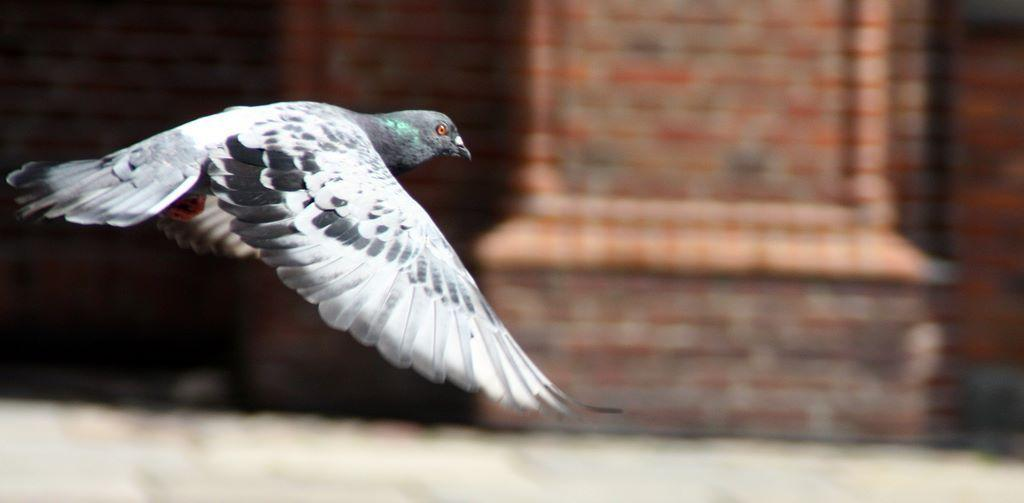What is the main subject of the image? There is a bird in the image. What is the bird doing in the image? The bird is flying in the air. Can you describe the bird's appearance? The bird has white and black coloring. How would you describe the background of the image? The background of the image is blurred. What hobbies does the bird have, as depicted in the image? The image does not provide information about the bird's hobbies. Is there a parcel being delivered by the bird in the image? There is no parcel present in the image. 